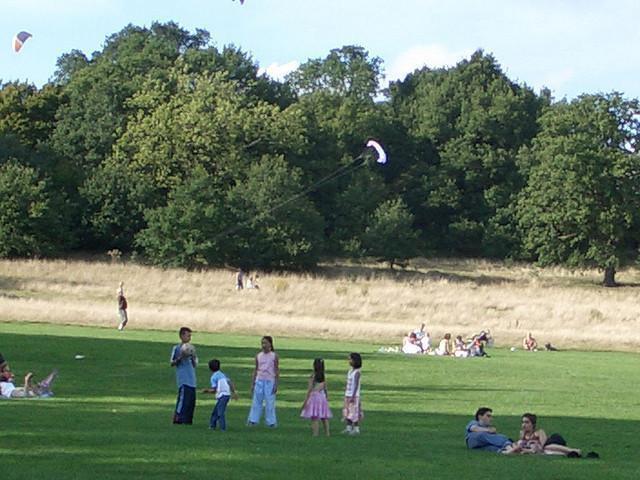How many people are there?
Give a very brief answer. 1. How many boats are between the land masses in the picture?
Give a very brief answer. 0. 